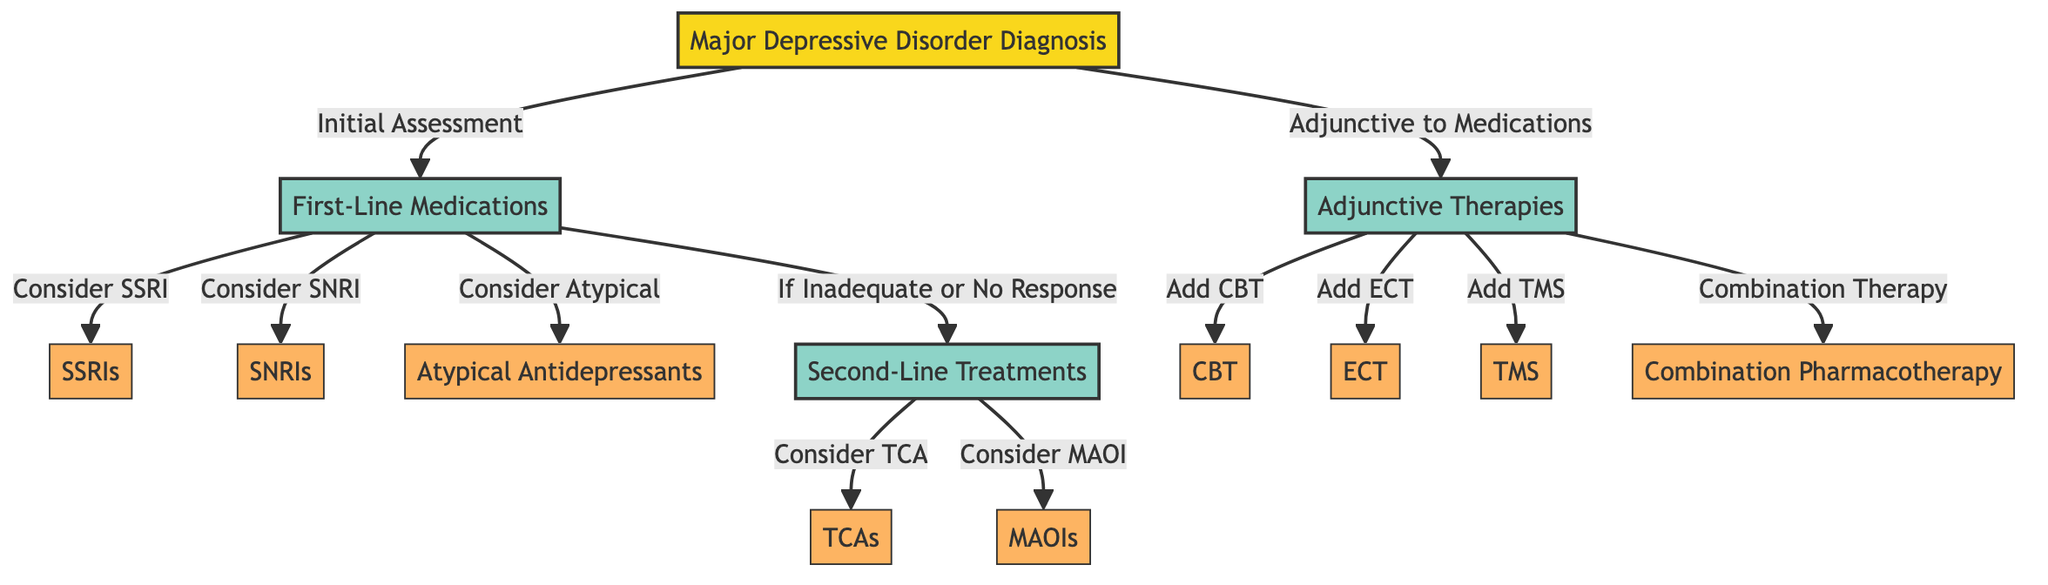What's the starting point of the treatment pathways? The diagram shows that the starting point is "Major Depressive Disorder Diagnosis." This node is labeled as the beginning of the pathway, clearly indicating where the process starts.
Answer: Major Depressive Disorder Diagnosis How many first-line medication options are presented? The diagram lists three first-line medication options: SSRIs, SNRIs, and Atypical Antidepressants. Counting these nodes shows there are a total of three options.
Answer: 3 What therapy is indicated as an adjunctive therapy? According to the diagram, Cognitive Behavioral Therapy (CBT) is specified as one of the adjunctive therapies available for major depressive disorder. It is directly connected to the "Adjunctive Therapies" node.
Answer: Cognitive Behavioral Therapy (CBT) What is the relationship between "Second-Line Treatments" and "Major Depressive Disorder Diagnosis"? The "Second-Line Treatments" category is connected to the "Major Depressive Disorder Diagnosis" node through an edge labeled "If Inadequate or No Response." This indicates that second-line treatments become relevant if first-line medications do not yield sufficient results.
Answer: If Inadequate or No Response What are the two types of medications listed under second-line treatments? The nodes "Tricyclic Antidepressants (TCAs)" and "Monoamine Oxidase Inhibitors (MAOIs)" are identified under the "Second-Line Treatments" category as the two medication options available. They are both categorized as second-line treatment options.
Answer: TCAs and MAOIs What is the consequence of the patient's initial assessment? Based on the diagram, the initial assessment leads to the "First-Line Medications" node, whereby patients are evaluated for various medication options. Thus, it indicates that the assessment drives the decision-making process towards medication choices.
Answer: First-Line Medications Which two adjunctive therapies can be added according to the diagram? The diagram mentions ECT and TMS as two adjunctive therapies available to be added. These nodes are connected to "Adjunctive Therapies," allowing for multiple support treatment options for patients.
Answer: ECT and TMS How many nodes are dedicated to medication options? There are a total of five nodes that represent medication options in the diagram: three from first-line (SSRIs, SNRIs, Atypical Antidepressants) and two from second-line treatments (TCAs and MAOIs). Adding these gives a total of five medication option nodes.
Answer: 5 What is the purpose of the directed arrows in this diagram? The directed arrows in the diagram illustrate the progression of treatment options and the relationships between different nodes. They help indicate how a psychiatrist may navigate through the pathways based on patient responses to treatment.
Answer: Indicate progression and relationships 